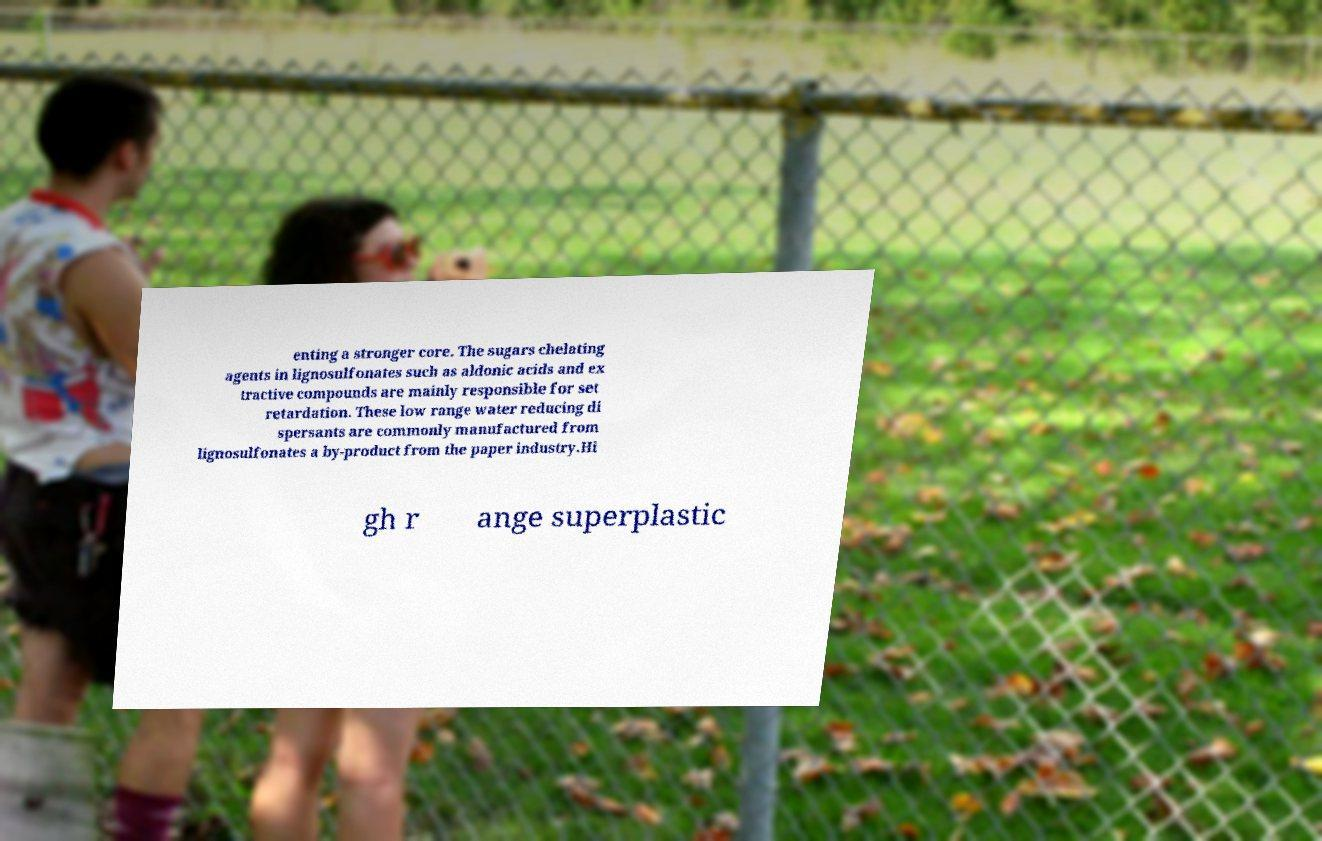Can you read and provide the text displayed in the image?This photo seems to have some interesting text. Can you extract and type it out for me? enting a stronger core. The sugars chelating agents in lignosulfonates such as aldonic acids and ex tractive compounds are mainly responsible for set retardation. These low range water reducing di spersants are commonly manufactured from lignosulfonates a by-product from the paper industry.Hi gh r ange superplastic 